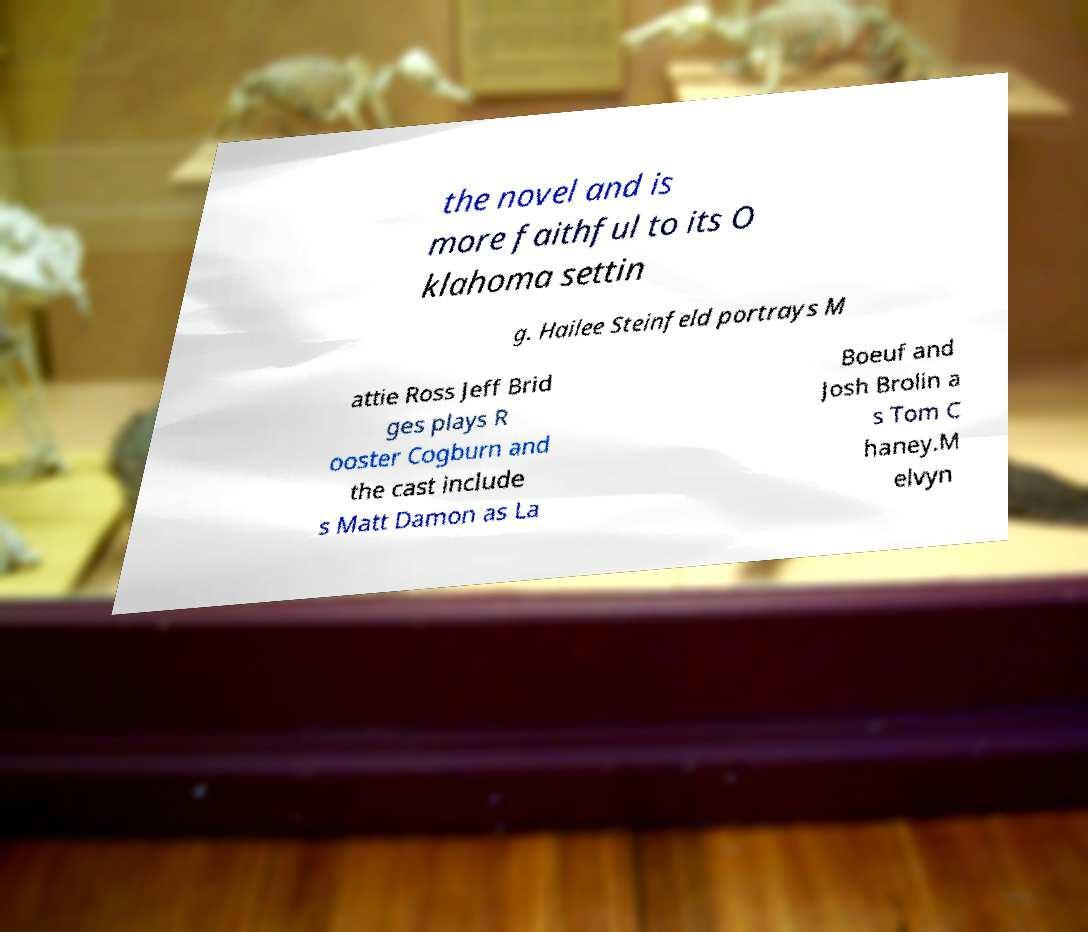Please read and relay the text visible in this image. What does it say? the novel and is more faithful to its O klahoma settin g. Hailee Steinfeld portrays M attie Ross Jeff Brid ges plays R ooster Cogburn and the cast include s Matt Damon as La Boeuf and Josh Brolin a s Tom C haney.M elvyn 